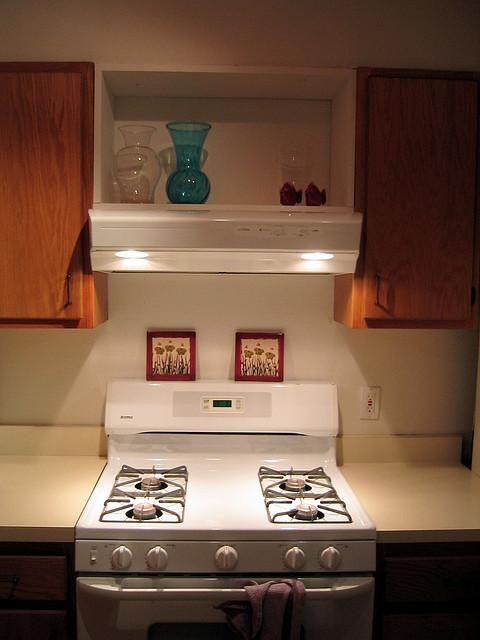What does the middle knob on the stove turn on? oven 